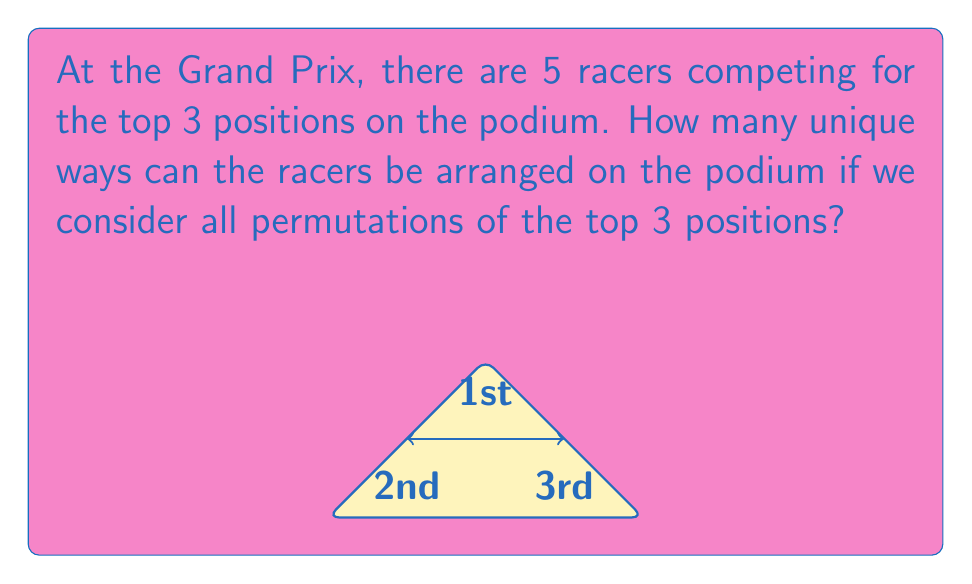Show me your answer to this math problem. To solve this problem, we'll use the concept of permutations from Abstract Algebra.

1) First, we need to understand what the question is asking:
   - We have 5 racers in total.
   - We're only arranging the top 3 positions.
   - The order of the racers on the podium matters (1st, 2nd, 3rd are distinct).

2) This scenario is a perfect application of permutations. Specifically, we're looking at permutations of 3 objects (podium positions) chosen from 5 objects (racers).

3) The formula for this type of permutation is:

   $$P(n,r) = \frac{n!}{(n-r)!}$$

   Where $n$ is the total number of objects (racers) and $r$ is the number of objects being arranged (podium positions).

4) In this case, $n = 5$ and $r = 3$. Let's substitute these values:

   $$P(5,3) = \frac{5!}{(5-3)!} = \frac{5!}{2!}$$

5) Expand this:
   $$\frac{5 \times 4 \times 3 \times 2!}{2!}$$

6) The $2!$ cancels out:
   $$5 \times 4 \times 3 = 60$$

Therefore, there are 60 unique ways to arrange the racers on the podium.
Answer: 60 